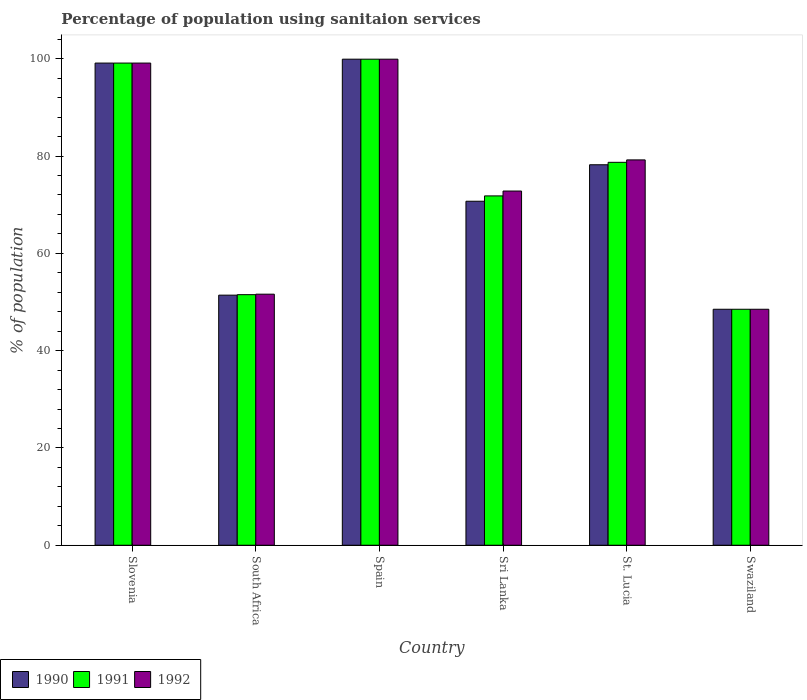How many different coloured bars are there?
Your answer should be very brief. 3. Are the number of bars per tick equal to the number of legend labels?
Your response must be concise. Yes. Are the number of bars on each tick of the X-axis equal?
Give a very brief answer. Yes. What is the label of the 5th group of bars from the left?
Provide a short and direct response. St. Lucia. In how many cases, is the number of bars for a given country not equal to the number of legend labels?
Offer a very short reply. 0. What is the percentage of population using sanitaion services in 1990 in Swaziland?
Keep it short and to the point. 48.5. Across all countries, what is the maximum percentage of population using sanitaion services in 1991?
Your answer should be compact. 99.9. Across all countries, what is the minimum percentage of population using sanitaion services in 1990?
Your answer should be compact. 48.5. In which country was the percentage of population using sanitaion services in 1991 maximum?
Your answer should be very brief. Spain. In which country was the percentage of population using sanitaion services in 1991 minimum?
Give a very brief answer. Swaziland. What is the total percentage of population using sanitaion services in 1991 in the graph?
Make the answer very short. 449.5. What is the difference between the percentage of population using sanitaion services in 1991 in Slovenia and that in Sri Lanka?
Your answer should be compact. 27.3. What is the difference between the percentage of population using sanitaion services in 1991 in St. Lucia and the percentage of population using sanitaion services in 1992 in Swaziland?
Give a very brief answer. 30.2. What is the average percentage of population using sanitaion services in 1991 per country?
Your response must be concise. 74.92. What is the ratio of the percentage of population using sanitaion services in 1991 in Spain to that in Sri Lanka?
Ensure brevity in your answer.  1.39. What is the difference between the highest and the second highest percentage of population using sanitaion services in 1992?
Keep it short and to the point. -0.8. What is the difference between the highest and the lowest percentage of population using sanitaion services in 1992?
Offer a terse response. 51.4. Is the sum of the percentage of population using sanitaion services in 1991 in Spain and Sri Lanka greater than the maximum percentage of population using sanitaion services in 1990 across all countries?
Your answer should be very brief. Yes. What does the 3rd bar from the right in Slovenia represents?
Ensure brevity in your answer.  1990. Is it the case that in every country, the sum of the percentage of population using sanitaion services in 1990 and percentage of population using sanitaion services in 1991 is greater than the percentage of population using sanitaion services in 1992?
Make the answer very short. Yes. How many countries are there in the graph?
Your response must be concise. 6. Does the graph contain any zero values?
Give a very brief answer. No. Where does the legend appear in the graph?
Give a very brief answer. Bottom left. How are the legend labels stacked?
Offer a terse response. Horizontal. What is the title of the graph?
Keep it short and to the point. Percentage of population using sanitaion services. What is the label or title of the X-axis?
Keep it short and to the point. Country. What is the label or title of the Y-axis?
Make the answer very short. % of population. What is the % of population of 1990 in Slovenia?
Keep it short and to the point. 99.1. What is the % of population in 1991 in Slovenia?
Offer a very short reply. 99.1. What is the % of population in 1992 in Slovenia?
Provide a succinct answer. 99.1. What is the % of population of 1990 in South Africa?
Make the answer very short. 51.4. What is the % of population in 1991 in South Africa?
Keep it short and to the point. 51.5. What is the % of population of 1992 in South Africa?
Keep it short and to the point. 51.6. What is the % of population in 1990 in Spain?
Your response must be concise. 99.9. What is the % of population of 1991 in Spain?
Offer a terse response. 99.9. What is the % of population of 1992 in Spain?
Make the answer very short. 99.9. What is the % of population of 1990 in Sri Lanka?
Provide a succinct answer. 70.7. What is the % of population of 1991 in Sri Lanka?
Your answer should be very brief. 71.8. What is the % of population of 1992 in Sri Lanka?
Offer a terse response. 72.8. What is the % of population of 1990 in St. Lucia?
Offer a very short reply. 78.2. What is the % of population in 1991 in St. Lucia?
Give a very brief answer. 78.7. What is the % of population of 1992 in St. Lucia?
Ensure brevity in your answer.  79.2. What is the % of population of 1990 in Swaziland?
Give a very brief answer. 48.5. What is the % of population in 1991 in Swaziland?
Make the answer very short. 48.5. What is the % of population in 1992 in Swaziland?
Make the answer very short. 48.5. Across all countries, what is the maximum % of population of 1990?
Your answer should be compact. 99.9. Across all countries, what is the maximum % of population in 1991?
Give a very brief answer. 99.9. Across all countries, what is the maximum % of population in 1992?
Provide a succinct answer. 99.9. Across all countries, what is the minimum % of population of 1990?
Your answer should be compact. 48.5. Across all countries, what is the minimum % of population of 1991?
Make the answer very short. 48.5. Across all countries, what is the minimum % of population in 1992?
Your answer should be very brief. 48.5. What is the total % of population of 1990 in the graph?
Make the answer very short. 447.8. What is the total % of population in 1991 in the graph?
Provide a succinct answer. 449.5. What is the total % of population in 1992 in the graph?
Keep it short and to the point. 451.1. What is the difference between the % of population of 1990 in Slovenia and that in South Africa?
Offer a very short reply. 47.7. What is the difference between the % of population of 1991 in Slovenia and that in South Africa?
Keep it short and to the point. 47.6. What is the difference between the % of population in 1992 in Slovenia and that in South Africa?
Make the answer very short. 47.5. What is the difference between the % of population of 1991 in Slovenia and that in Spain?
Give a very brief answer. -0.8. What is the difference between the % of population of 1992 in Slovenia and that in Spain?
Provide a succinct answer. -0.8. What is the difference between the % of population in 1990 in Slovenia and that in Sri Lanka?
Your response must be concise. 28.4. What is the difference between the % of population of 1991 in Slovenia and that in Sri Lanka?
Your response must be concise. 27.3. What is the difference between the % of population in 1992 in Slovenia and that in Sri Lanka?
Give a very brief answer. 26.3. What is the difference between the % of population in 1990 in Slovenia and that in St. Lucia?
Provide a short and direct response. 20.9. What is the difference between the % of population in 1991 in Slovenia and that in St. Lucia?
Your answer should be very brief. 20.4. What is the difference between the % of population in 1990 in Slovenia and that in Swaziland?
Your answer should be very brief. 50.6. What is the difference between the % of population in 1991 in Slovenia and that in Swaziland?
Make the answer very short. 50.6. What is the difference between the % of population in 1992 in Slovenia and that in Swaziland?
Give a very brief answer. 50.6. What is the difference between the % of population in 1990 in South Africa and that in Spain?
Provide a succinct answer. -48.5. What is the difference between the % of population of 1991 in South Africa and that in Spain?
Your answer should be compact. -48.4. What is the difference between the % of population of 1992 in South Africa and that in Spain?
Your answer should be very brief. -48.3. What is the difference between the % of population of 1990 in South Africa and that in Sri Lanka?
Ensure brevity in your answer.  -19.3. What is the difference between the % of population in 1991 in South Africa and that in Sri Lanka?
Your response must be concise. -20.3. What is the difference between the % of population in 1992 in South Africa and that in Sri Lanka?
Offer a very short reply. -21.2. What is the difference between the % of population of 1990 in South Africa and that in St. Lucia?
Provide a succinct answer. -26.8. What is the difference between the % of population in 1991 in South Africa and that in St. Lucia?
Keep it short and to the point. -27.2. What is the difference between the % of population in 1992 in South Africa and that in St. Lucia?
Make the answer very short. -27.6. What is the difference between the % of population in 1990 in Spain and that in Sri Lanka?
Your response must be concise. 29.2. What is the difference between the % of population of 1991 in Spain and that in Sri Lanka?
Ensure brevity in your answer.  28.1. What is the difference between the % of population in 1992 in Spain and that in Sri Lanka?
Your response must be concise. 27.1. What is the difference between the % of population in 1990 in Spain and that in St. Lucia?
Make the answer very short. 21.7. What is the difference between the % of population in 1991 in Spain and that in St. Lucia?
Your answer should be very brief. 21.2. What is the difference between the % of population in 1992 in Spain and that in St. Lucia?
Provide a short and direct response. 20.7. What is the difference between the % of population in 1990 in Spain and that in Swaziland?
Give a very brief answer. 51.4. What is the difference between the % of population in 1991 in Spain and that in Swaziland?
Keep it short and to the point. 51.4. What is the difference between the % of population in 1992 in Spain and that in Swaziland?
Give a very brief answer. 51.4. What is the difference between the % of population of 1991 in Sri Lanka and that in Swaziland?
Your answer should be very brief. 23.3. What is the difference between the % of population in 1992 in Sri Lanka and that in Swaziland?
Make the answer very short. 24.3. What is the difference between the % of population in 1990 in St. Lucia and that in Swaziland?
Provide a short and direct response. 29.7. What is the difference between the % of population of 1991 in St. Lucia and that in Swaziland?
Make the answer very short. 30.2. What is the difference between the % of population in 1992 in St. Lucia and that in Swaziland?
Provide a short and direct response. 30.7. What is the difference between the % of population of 1990 in Slovenia and the % of population of 1991 in South Africa?
Keep it short and to the point. 47.6. What is the difference between the % of population in 1990 in Slovenia and the % of population in 1992 in South Africa?
Your answer should be compact. 47.5. What is the difference between the % of population in 1991 in Slovenia and the % of population in 1992 in South Africa?
Give a very brief answer. 47.5. What is the difference between the % of population in 1990 in Slovenia and the % of population in 1992 in Spain?
Keep it short and to the point. -0.8. What is the difference between the % of population of 1990 in Slovenia and the % of population of 1991 in Sri Lanka?
Make the answer very short. 27.3. What is the difference between the % of population of 1990 in Slovenia and the % of population of 1992 in Sri Lanka?
Keep it short and to the point. 26.3. What is the difference between the % of population of 1991 in Slovenia and the % of population of 1992 in Sri Lanka?
Ensure brevity in your answer.  26.3. What is the difference between the % of population of 1990 in Slovenia and the % of population of 1991 in St. Lucia?
Your answer should be compact. 20.4. What is the difference between the % of population in 1990 in Slovenia and the % of population in 1992 in St. Lucia?
Your answer should be very brief. 19.9. What is the difference between the % of population of 1991 in Slovenia and the % of population of 1992 in St. Lucia?
Give a very brief answer. 19.9. What is the difference between the % of population of 1990 in Slovenia and the % of population of 1991 in Swaziland?
Give a very brief answer. 50.6. What is the difference between the % of population of 1990 in Slovenia and the % of population of 1992 in Swaziland?
Make the answer very short. 50.6. What is the difference between the % of population in 1991 in Slovenia and the % of population in 1992 in Swaziland?
Keep it short and to the point. 50.6. What is the difference between the % of population in 1990 in South Africa and the % of population in 1991 in Spain?
Your answer should be very brief. -48.5. What is the difference between the % of population in 1990 in South Africa and the % of population in 1992 in Spain?
Give a very brief answer. -48.5. What is the difference between the % of population in 1991 in South Africa and the % of population in 1992 in Spain?
Offer a very short reply. -48.4. What is the difference between the % of population in 1990 in South Africa and the % of population in 1991 in Sri Lanka?
Make the answer very short. -20.4. What is the difference between the % of population in 1990 in South Africa and the % of population in 1992 in Sri Lanka?
Give a very brief answer. -21.4. What is the difference between the % of population in 1991 in South Africa and the % of population in 1992 in Sri Lanka?
Your answer should be very brief. -21.3. What is the difference between the % of population of 1990 in South Africa and the % of population of 1991 in St. Lucia?
Give a very brief answer. -27.3. What is the difference between the % of population of 1990 in South Africa and the % of population of 1992 in St. Lucia?
Offer a terse response. -27.8. What is the difference between the % of population in 1991 in South Africa and the % of population in 1992 in St. Lucia?
Give a very brief answer. -27.7. What is the difference between the % of population of 1990 in South Africa and the % of population of 1991 in Swaziland?
Ensure brevity in your answer.  2.9. What is the difference between the % of population of 1990 in South Africa and the % of population of 1992 in Swaziland?
Ensure brevity in your answer.  2.9. What is the difference between the % of population of 1990 in Spain and the % of population of 1991 in Sri Lanka?
Provide a short and direct response. 28.1. What is the difference between the % of population in 1990 in Spain and the % of population in 1992 in Sri Lanka?
Give a very brief answer. 27.1. What is the difference between the % of population in 1991 in Spain and the % of population in 1992 in Sri Lanka?
Offer a terse response. 27.1. What is the difference between the % of population in 1990 in Spain and the % of population in 1991 in St. Lucia?
Offer a very short reply. 21.2. What is the difference between the % of population in 1990 in Spain and the % of population in 1992 in St. Lucia?
Provide a short and direct response. 20.7. What is the difference between the % of population of 1991 in Spain and the % of population of 1992 in St. Lucia?
Provide a short and direct response. 20.7. What is the difference between the % of population of 1990 in Spain and the % of population of 1991 in Swaziland?
Your response must be concise. 51.4. What is the difference between the % of population in 1990 in Spain and the % of population in 1992 in Swaziland?
Give a very brief answer. 51.4. What is the difference between the % of population of 1991 in Spain and the % of population of 1992 in Swaziland?
Ensure brevity in your answer.  51.4. What is the difference between the % of population in 1990 in Sri Lanka and the % of population in 1991 in St. Lucia?
Make the answer very short. -8. What is the difference between the % of population in 1990 in Sri Lanka and the % of population in 1992 in St. Lucia?
Make the answer very short. -8.5. What is the difference between the % of population in 1991 in Sri Lanka and the % of population in 1992 in Swaziland?
Your response must be concise. 23.3. What is the difference between the % of population in 1990 in St. Lucia and the % of population in 1991 in Swaziland?
Give a very brief answer. 29.7. What is the difference between the % of population of 1990 in St. Lucia and the % of population of 1992 in Swaziland?
Give a very brief answer. 29.7. What is the difference between the % of population of 1991 in St. Lucia and the % of population of 1992 in Swaziland?
Offer a terse response. 30.2. What is the average % of population in 1990 per country?
Your response must be concise. 74.63. What is the average % of population of 1991 per country?
Give a very brief answer. 74.92. What is the average % of population of 1992 per country?
Give a very brief answer. 75.18. What is the difference between the % of population of 1991 and % of population of 1992 in Slovenia?
Make the answer very short. 0. What is the difference between the % of population of 1990 and % of population of 1991 in South Africa?
Ensure brevity in your answer.  -0.1. What is the difference between the % of population in 1990 and % of population in 1991 in Sri Lanka?
Give a very brief answer. -1.1. What is the difference between the % of population of 1990 and % of population of 1991 in Swaziland?
Provide a succinct answer. 0. What is the difference between the % of population of 1990 and % of population of 1992 in Swaziland?
Provide a short and direct response. 0. What is the difference between the % of population of 1991 and % of population of 1992 in Swaziland?
Give a very brief answer. 0. What is the ratio of the % of population of 1990 in Slovenia to that in South Africa?
Offer a very short reply. 1.93. What is the ratio of the % of population in 1991 in Slovenia to that in South Africa?
Offer a very short reply. 1.92. What is the ratio of the % of population in 1992 in Slovenia to that in South Africa?
Offer a terse response. 1.92. What is the ratio of the % of population in 1991 in Slovenia to that in Spain?
Provide a short and direct response. 0.99. What is the ratio of the % of population of 1992 in Slovenia to that in Spain?
Offer a very short reply. 0.99. What is the ratio of the % of population of 1990 in Slovenia to that in Sri Lanka?
Offer a terse response. 1.4. What is the ratio of the % of population of 1991 in Slovenia to that in Sri Lanka?
Give a very brief answer. 1.38. What is the ratio of the % of population of 1992 in Slovenia to that in Sri Lanka?
Provide a succinct answer. 1.36. What is the ratio of the % of population of 1990 in Slovenia to that in St. Lucia?
Keep it short and to the point. 1.27. What is the ratio of the % of population of 1991 in Slovenia to that in St. Lucia?
Your answer should be very brief. 1.26. What is the ratio of the % of population in 1992 in Slovenia to that in St. Lucia?
Your answer should be compact. 1.25. What is the ratio of the % of population in 1990 in Slovenia to that in Swaziland?
Give a very brief answer. 2.04. What is the ratio of the % of population in 1991 in Slovenia to that in Swaziland?
Your answer should be compact. 2.04. What is the ratio of the % of population of 1992 in Slovenia to that in Swaziland?
Your response must be concise. 2.04. What is the ratio of the % of population in 1990 in South Africa to that in Spain?
Give a very brief answer. 0.51. What is the ratio of the % of population of 1991 in South Africa to that in Spain?
Give a very brief answer. 0.52. What is the ratio of the % of population in 1992 in South Africa to that in Spain?
Your answer should be compact. 0.52. What is the ratio of the % of population of 1990 in South Africa to that in Sri Lanka?
Make the answer very short. 0.73. What is the ratio of the % of population of 1991 in South Africa to that in Sri Lanka?
Your answer should be compact. 0.72. What is the ratio of the % of population of 1992 in South Africa to that in Sri Lanka?
Your response must be concise. 0.71. What is the ratio of the % of population in 1990 in South Africa to that in St. Lucia?
Offer a terse response. 0.66. What is the ratio of the % of population of 1991 in South Africa to that in St. Lucia?
Your response must be concise. 0.65. What is the ratio of the % of population of 1992 in South Africa to that in St. Lucia?
Provide a short and direct response. 0.65. What is the ratio of the % of population of 1990 in South Africa to that in Swaziland?
Offer a terse response. 1.06. What is the ratio of the % of population of 1991 in South Africa to that in Swaziland?
Offer a terse response. 1.06. What is the ratio of the % of population of 1992 in South Africa to that in Swaziland?
Your answer should be compact. 1.06. What is the ratio of the % of population of 1990 in Spain to that in Sri Lanka?
Keep it short and to the point. 1.41. What is the ratio of the % of population in 1991 in Spain to that in Sri Lanka?
Your answer should be compact. 1.39. What is the ratio of the % of population in 1992 in Spain to that in Sri Lanka?
Provide a succinct answer. 1.37. What is the ratio of the % of population of 1990 in Spain to that in St. Lucia?
Offer a very short reply. 1.28. What is the ratio of the % of population of 1991 in Spain to that in St. Lucia?
Your answer should be compact. 1.27. What is the ratio of the % of population in 1992 in Spain to that in St. Lucia?
Offer a very short reply. 1.26. What is the ratio of the % of population of 1990 in Spain to that in Swaziland?
Give a very brief answer. 2.06. What is the ratio of the % of population of 1991 in Spain to that in Swaziland?
Keep it short and to the point. 2.06. What is the ratio of the % of population of 1992 in Spain to that in Swaziland?
Ensure brevity in your answer.  2.06. What is the ratio of the % of population of 1990 in Sri Lanka to that in St. Lucia?
Offer a very short reply. 0.9. What is the ratio of the % of population of 1991 in Sri Lanka to that in St. Lucia?
Your response must be concise. 0.91. What is the ratio of the % of population of 1992 in Sri Lanka to that in St. Lucia?
Make the answer very short. 0.92. What is the ratio of the % of population of 1990 in Sri Lanka to that in Swaziland?
Make the answer very short. 1.46. What is the ratio of the % of population in 1991 in Sri Lanka to that in Swaziland?
Ensure brevity in your answer.  1.48. What is the ratio of the % of population in 1992 in Sri Lanka to that in Swaziland?
Keep it short and to the point. 1.5. What is the ratio of the % of population in 1990 in St. Lucia to that in Swaziland?
Provide a succinct answer. 1.61. What is the ratio of the % of population in 1991 in St. Lucia to that in Swaziland?
Give a very brief answer. 1.62. What is the ratio of the % of population of 1992 in St. Lucia to that in Swaziland?
Provide a short and direct response. 1.63. What is the difference between the highest and the second highest % of population in 1990?
Provide a succinct answer. 0.8. What is the difference between the highest and the lowest % of population of 1990?
Offer a terse response. 51.4. What is the difference between the highest and the lowest % of population in 1991?
Offer a very short reply. 51.4. What is the difference between the highest and the lowest % of population of 1992?
Provide a short and direct response. 51.4. 